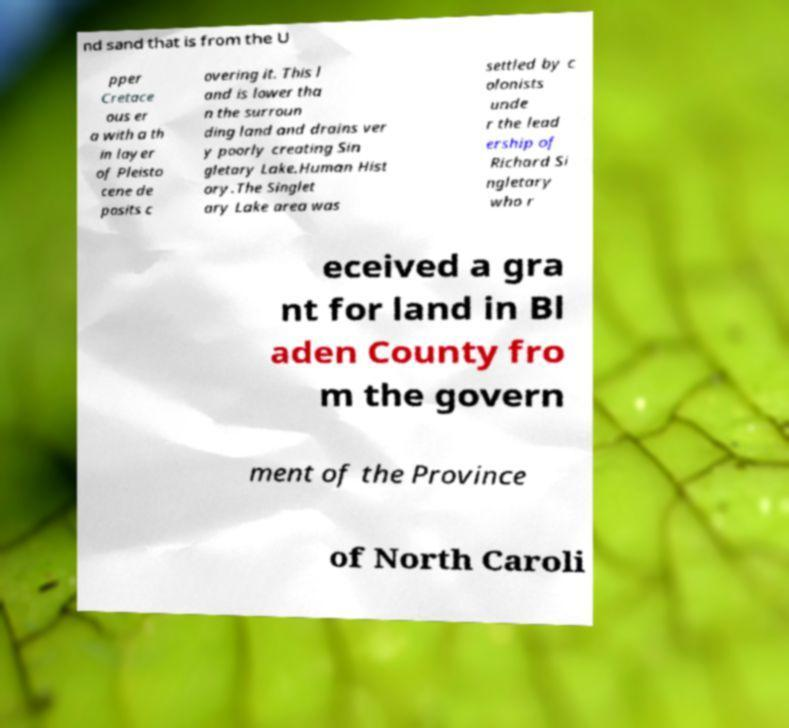What messages or text are displayed in this image? I need them in a readable, typed format. nd sand that is from the U pper Cretace ous er a with a th in layer of Pleisto cene de posits c overing it. This l and is lower tha n the surroun ding land and drains ver y poorly creating Sin gletary Lake.Human Hist ory.The Singlet ary Lake area was settled by c olonists unde r the lead ership of Richard Si ngletary who r eceived a gra nt for land in Bl aden County fro m the govern ment of the Province of North Caroli 